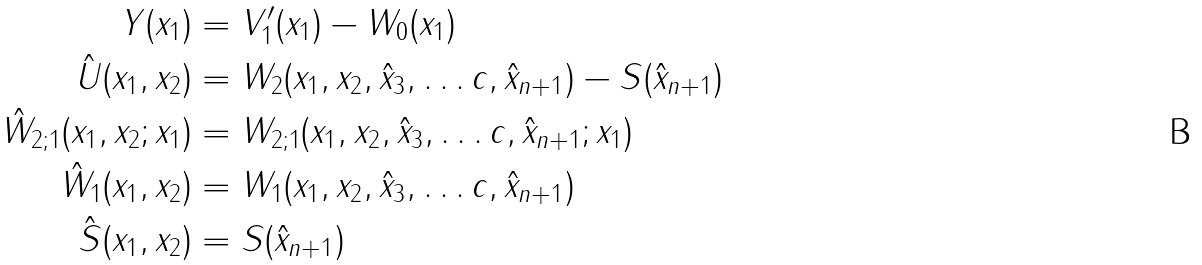<formula> <loc_0><loc_0><loc_500><loc_500>Y ( x _ { 1 } ) & = V ^ { \prime } _ { 1 } ( x _ { 1 } ) - W _ { 0 } ( x _ { 1 } ) \\ \hat { U } ( x _ { 1 } , x _ { 2 } ) & = W _ { 2 } ( x _ { 1 } , x _ { 2 } , \hat { x } _ { 3 } , \dots c , \hat { x } _ { n + 1 } ) - S ( \hat { x } _ { n + 1 } ) \\ \hat { W } _ { 2 ; 1 } ( x _ { 1 } , x _ { 2 } ; x _ { 1 } ) & = W _ { 2 ; 1 } ( x _ { 1 } , x _ { 2 } , \hat { x } _ { 3 } , \dots c , \hat { x } _ { n + 1 } ; x _ { 1 } ) \\ \hat { W } _ { 1 } ( x _ { 1 } , x _ { 2 } ) & = W _ { 1 } ( x _ { 1 } , x _ { 2 } , \hat { x } _ { 3 } , \dots c , \hat { x } _ { n + 1 } ) \\ \hat { S } ( x _ { 1 } , x _ { 2 } ) & = S ( \hat { x } _ { n + 1 } )</formula> 